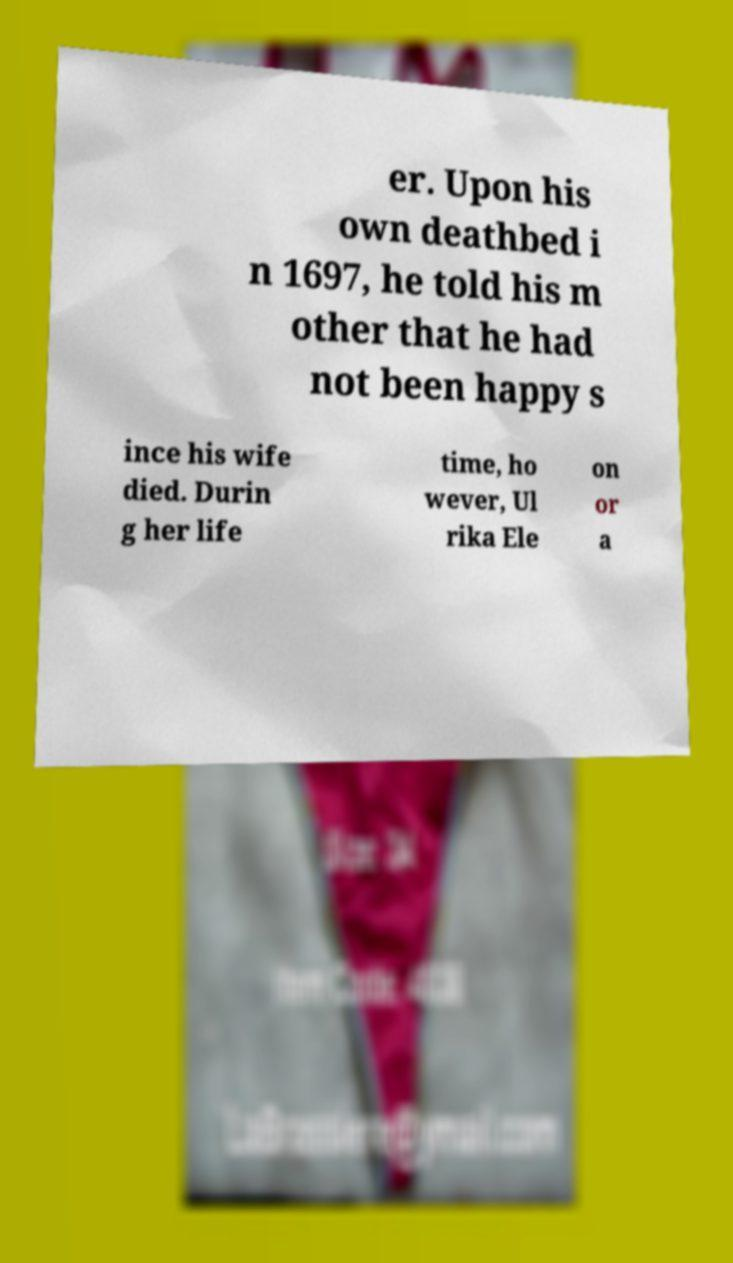I need the written content from this picture converted into text. Can you do that? er. Upon his own deathbed i n 1697, he told his m other that he had not been happy s ince his wife died. Durin g her life time, ho wever, Ul rika Ele on or a 